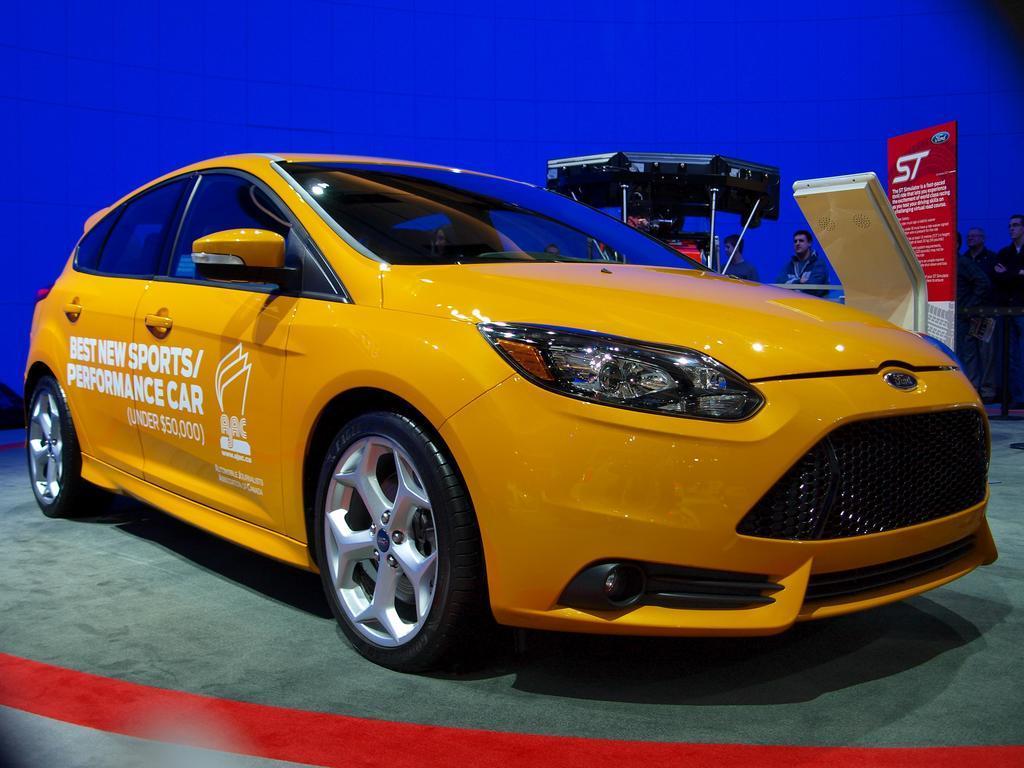In one or two sentences, can you explain what this image depicts? Background portion of the picture is in blue color. On the right side of the picture we can see the people, board and objects. In this picture we can see a car on the floor. 